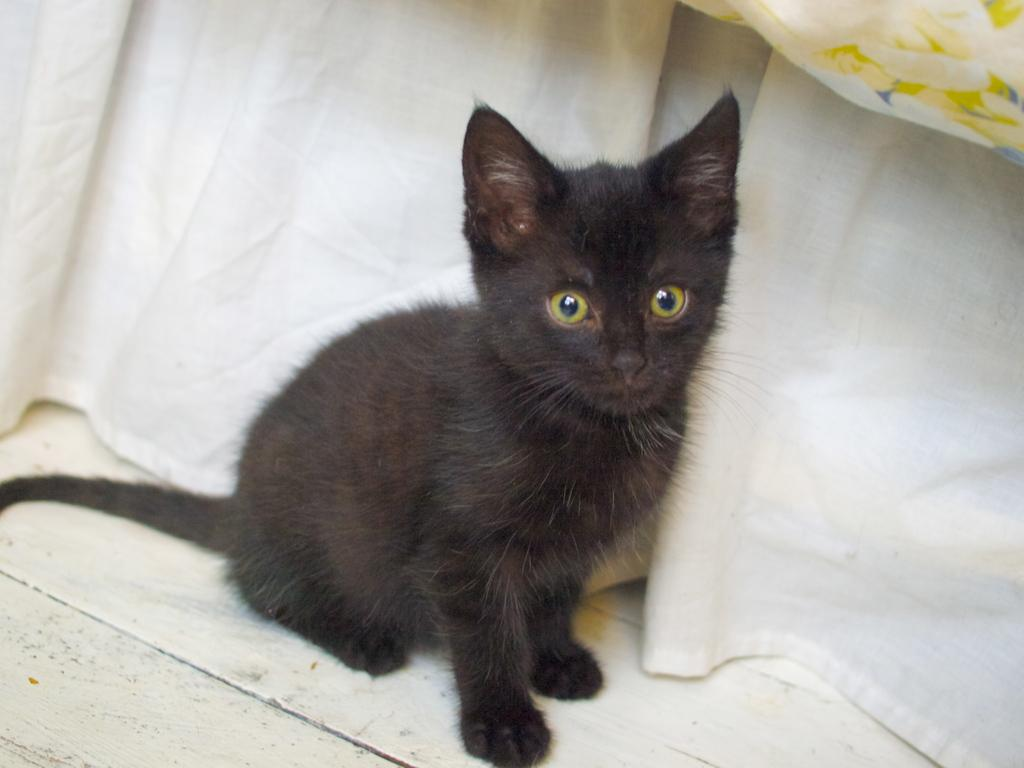What type of animal is in the image? There is a black cat in the image. What can be seen in the background of the image? There is a cloth visible in the background of the image. What is the manager doing in the image? There is no manager present in the image; it features a black cat and a cloth in the background. How does the moon affect the behavior of the cat in the image? The image does not show the moon or any indication of its effect on the cat's behavior. 